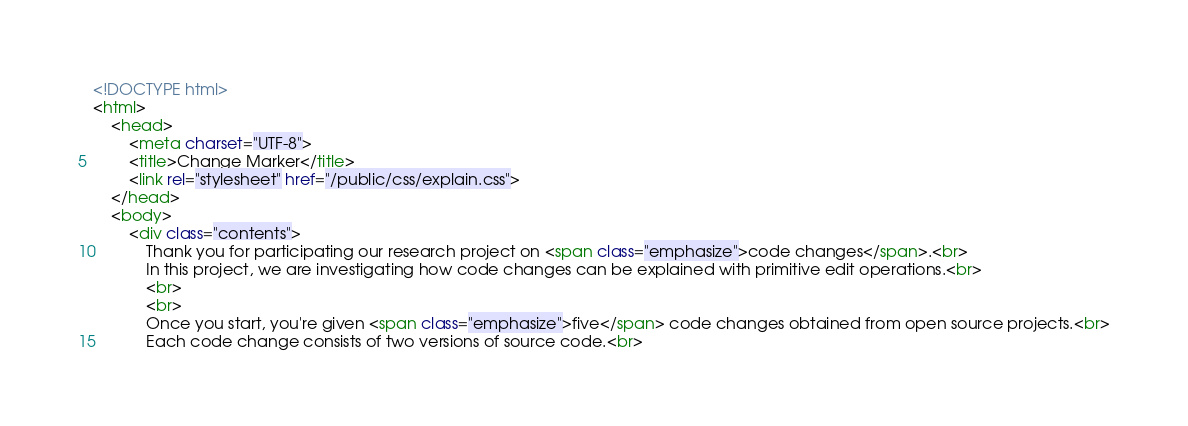Convert code to text. <code><loc_0><loc_0><loc_500><loc_500><_HTML_><!DOCTYPE html>
<html>
    <head>
        <meta charset="UTF-8">
        <title>Change Marker</title>
        <link rel="stylesheet" href="/public/css/explain.css">
    </head>
    <body>
        <div class="contents">
            Thank you for participating our research project on <span class="emphasize">code changes</span>.<br>
            In this project, we are investigating how code changes can be explained with primitive edit operations.<br>
            <br>
            <br>
            Once you start, you're given <span class="emphasize">five</span> code changes obtained from open source projects.<br>
            Each code change consists of two versions of source code.<br></code> 